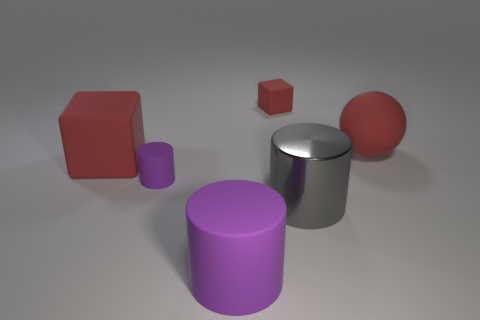Subtract all small cylinders. How many cylinders are left? 2 Add 1 blue rubber cylinders. How many objects exist? 7 Subtract 2 cylinders. How many cylinders are left? 1 Subtract all purple cylinders. How many cylinders are left? 1 Subtract all cubes. How many objects are left? 4 Subtract all yellow balls. How many purple cylinders are left? 2 Add 3 purple cylinders. How many purple cylinders exist? 5 Subtract 0 blue cylinders. How many objects are left? 6 Subtract all cyan cylinders. Subtract all blue balls. How many cylinders are left? 3 Subtract all large balls. Subtract all gray cylinders. How many objects are left? 4 